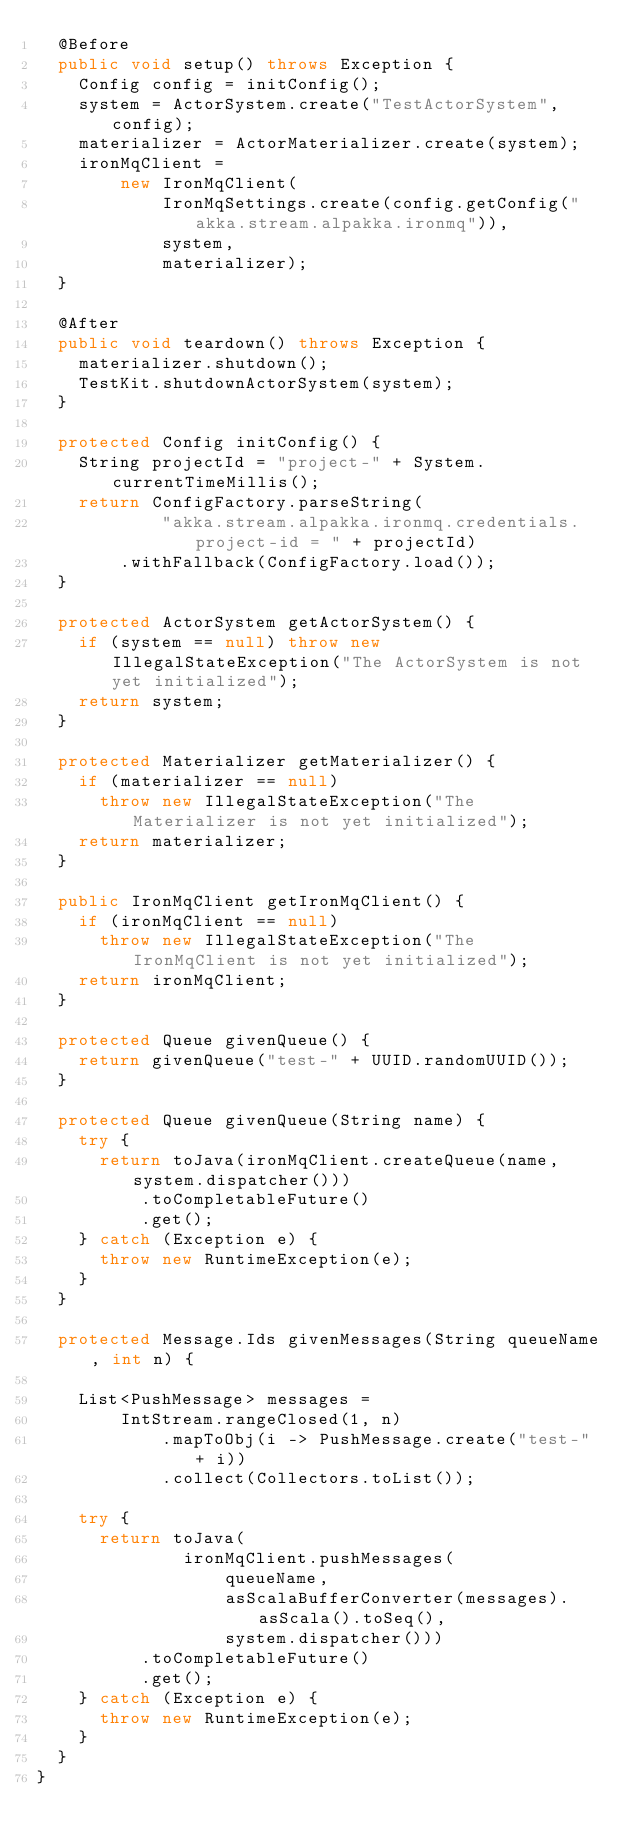<code> <loc_0><loc_0><loc_500><loc_500><_Java_>  @Before
  public void setup() throws Exception {
    Config config = initConfig();
    system = ActorSystem.create("TestActorSystem", config);
    materializer = ActorMaterializer.create(system);
    ironMqClient =
        new IronMqClient(
            IronMqSettings.create(config.getConfig("akka.stream.alpakka.ironmq")),
            system,
            materializer);
  }

  @After
  public void teardown() throws Exception {
    materializer.shutdown();
    TestKit.shutdownActorSystem(system);
  }

  protected Config initConfig() {
    String projectId = "project-" + System.currentTimeMillis();
    return ConfigFactory.parseString(
            "akka.stream.alpakka.ironmq.credentials.project-id = " + projectId)
        .withFallback(ConfigFactory.load());
  }

  protected ActorSystem getActorSystem() {
    if (system == null) throw new IllegalStateException("The ActorSystem is not yet initialized");
    return system;
  }

  protected Materializer getMaterializer() {
    if (materializer == null)
      throw new IllegalStateException("The Materializer is not yet initialized");
    return materializer;
  }

  public IronMqClient getIronMqClient() {
    if (ironMqClient == null)
      throw new IllegalStateException("The IronMqClient is not yet initialized");
    return ironMqClient;
  }

  protected Queue givenQueue() {
    return givenQueue("test-" + UUID.randomUUID());
  }

  protected Queue givenQueue(String name) {
    try {
      return toJava(ironMqClient.createQueue(name, system.dispatcher()))
          .toCompletableFuture()
          .get();
    } catch (Exception e) {
      throw new RuntimeException(e);
    }
  }

  protected Message.Ids givenMessages(String queueName, int n) {

    List<PushMessage> messages =
        IntStream.rangeClosed(1, n)
            .mapToObj(i -> PushMessage.create("test-" + i))
            .collect(Collectors.toList());

    try {
      return toJava(
              ironMqClient.pushMessages(
                  queueName,
                  asScalaBufferConverter(messages).asScala().toSeq(),
                  system.dispatcher()))
          .toCompletableFuture()
          .get();
    } catch (Exception e) {
      throw new RuntimeException(e);
    }
  }
}
</code> 